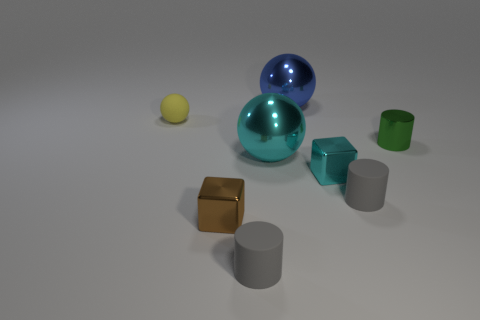Is the number of tiny brown matte blocks greater than the number of yellow matte things? In the image, there appears to be one tiny brown matte block and one yellow matte sphere. Thus, the number of tiny brown matte blocks is equal to the number of yellow matte things; neither is greater than the other. 